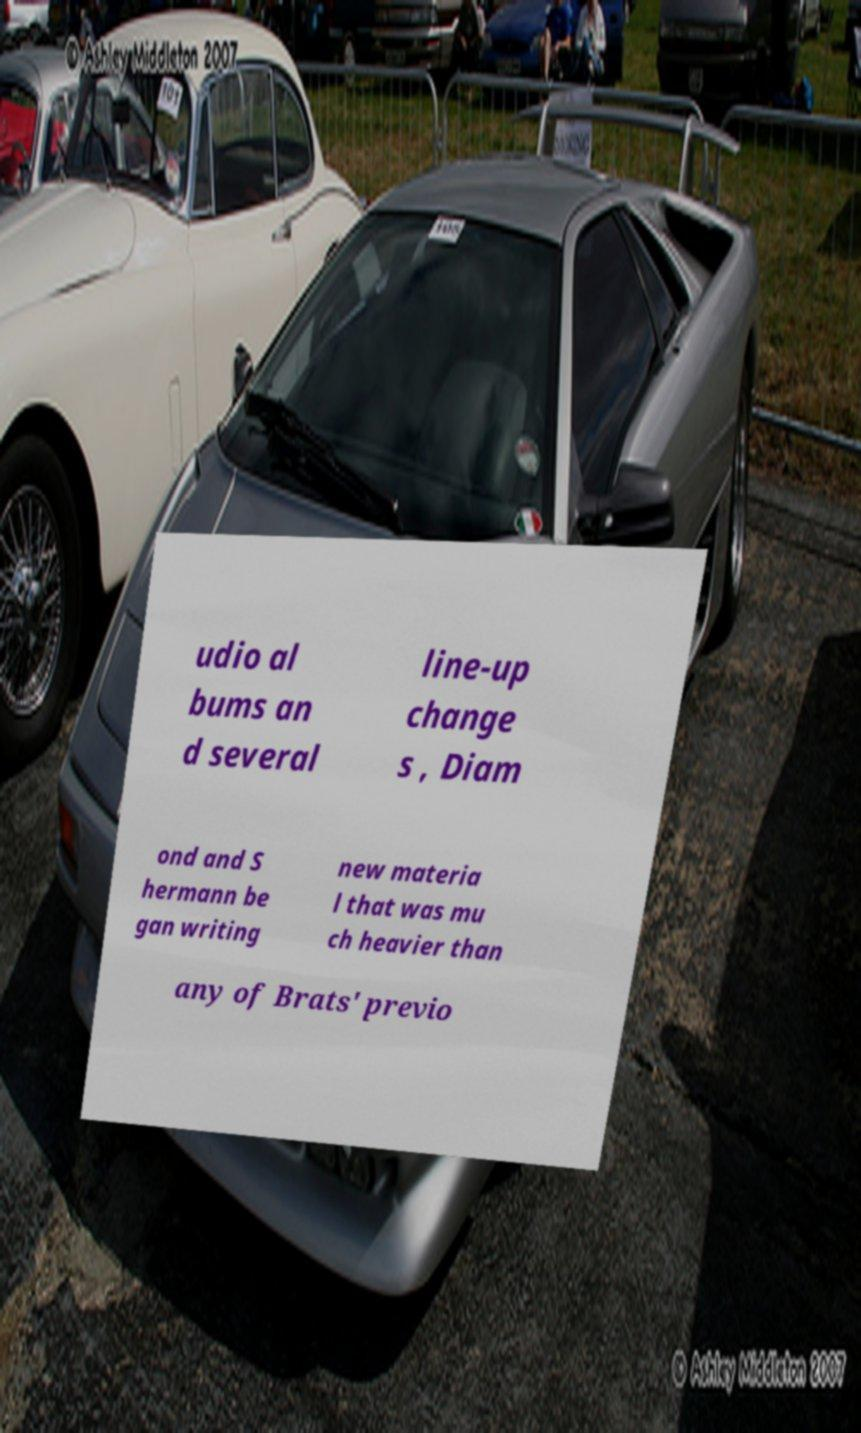What messages or text are displayed in this image? I need them in a readable, typed format. udio al bums an d several line-up change s , Diam ond and S hermann be gan writing new materia l that was mu ch heavier than any of Brats' previo 